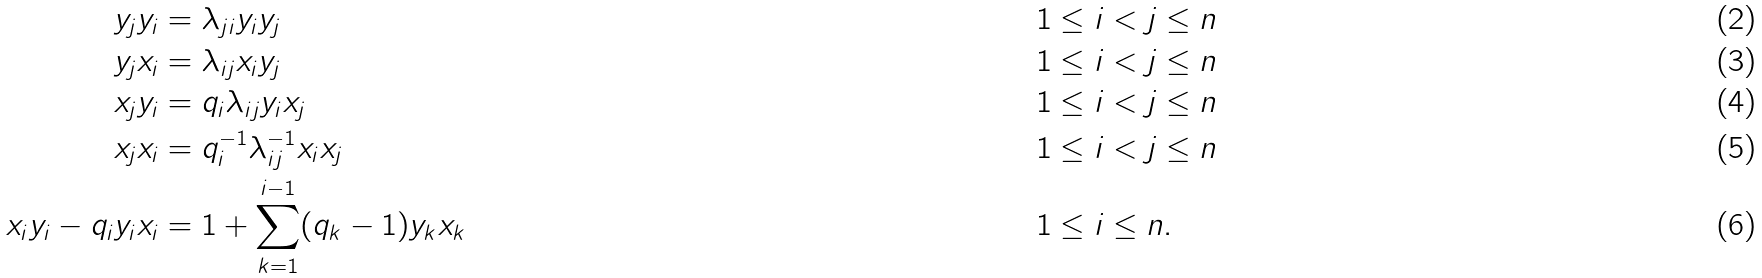<formula> <loc_0><loc_0><loc_500><loc_500>y _ { j } y _ { i } & = { \lambda } _ { j i } y _ { i } y _ { j } & & 1 \leq i < j \leq n \\ y _ { j } x _ { i } & = { \lambda } _ { i j } x _ { i } y _ { j } & & 1 \leq i < j \leq n \\ x _ { j } y _ { i } & = { q } _ { i } { \lambda } _ { i j } y _ { i } x _ { j } & & 1 \leq i < j \leq n \\ x _ { j } x _ { i } & = { q } _ { i } ^ { - 1 } { \lambda } _ { i j } ^ { - 1 } x _ { i } x _ { j } & & 1 \leq i < j \leq n \\ x _ { i } y _ { i } - { q } _ { i } y _ { i } x _ { i } & = 1 + \sum _ { k = 1 } ^ { i - 1 } ( q _ { k } - 1 ) y _ { k } x _ { k } & \quad & 1 \leq i \leq n .</formula> 